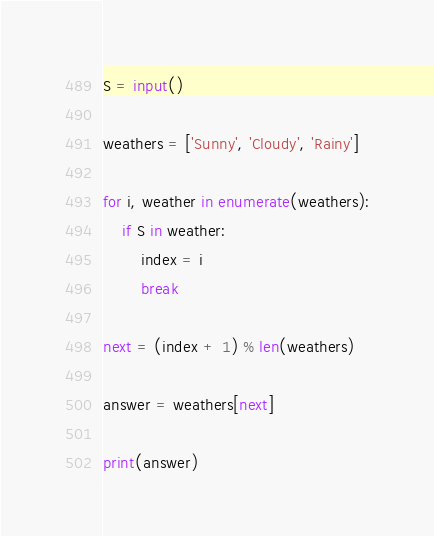<code> <loc_0><loc_0><loc_500><loc_500><_Python_>S = input()

weathers = ['Sunny', 'Cloudy', 'Rainy']

for i, weather in enumerate(weathers):
    if S in weather:
        index = i
        break

next = (index + 1) % len(weathers)

answer = weathers[next]

print(answer)
</code> 